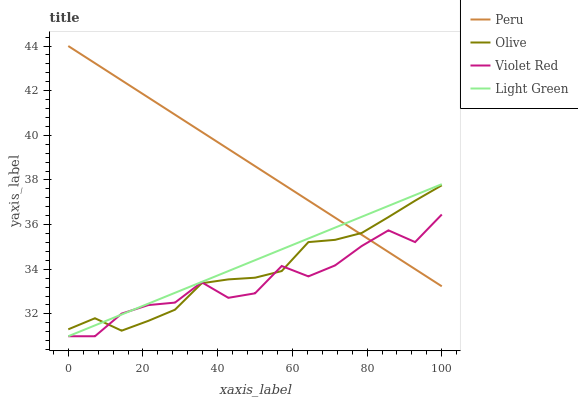Does Light Green have the minimum area under the curve?
Answer yes or no. No. Does Light Green have the maximum area under the curve?
Answer yes or no. No. Is Light Green the smoothest?
Answer yes or no. No. Is Light Green the roughest?
Answer yes or no. No. Does Peru have the lowest value?
Answer yes or no. No. Does Light Green have the highest value?
Answer yes or no. No. 